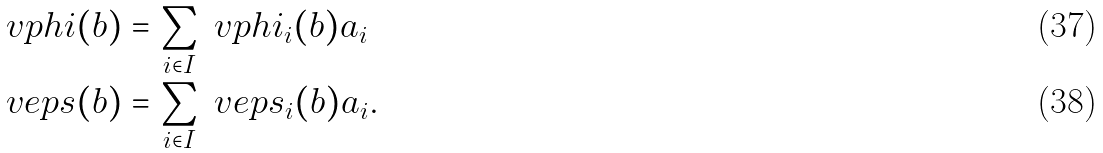<formula> <loc_0><loc_0><loc_500><loc_500>\ v p h i ( b ) & = \sum _ { i \in I } \ v p h i _ { i } ( b ) \L a _ { i } \\ \ v e p s ( b ) & = \sum _ { i \in I } \ v e p s _ { i } ( b ) \L a _ { i } .</formula> 